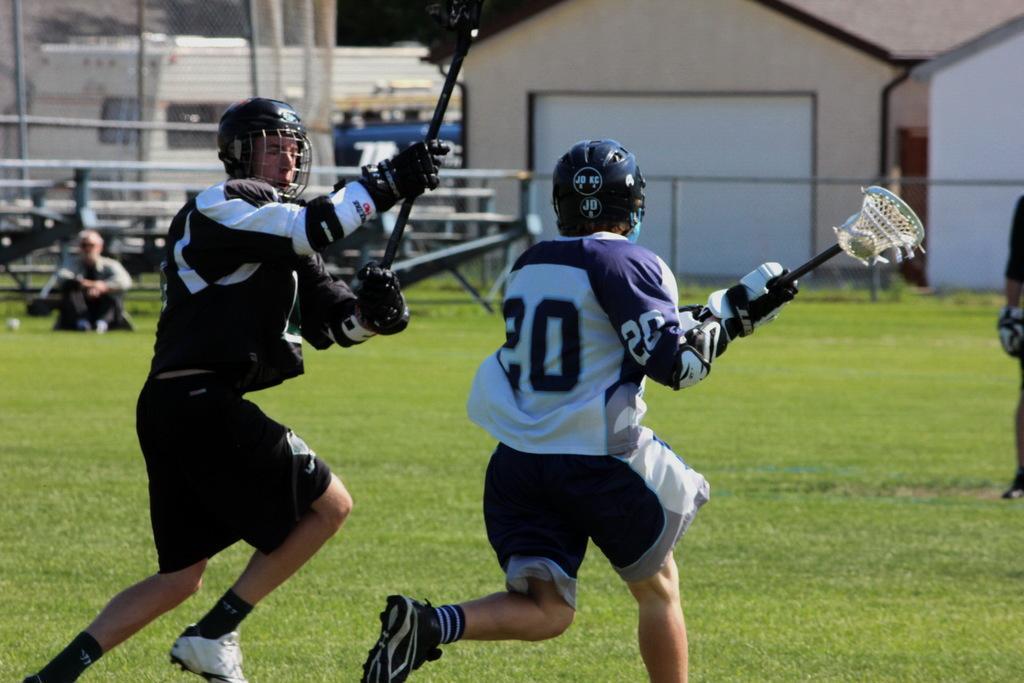In one or two sentences, can you explain what this image depicts? In the foreground of the picture there are players playing. In the foreground of the picture there is grass. In the background there are buildings, railing, branches and a person. 